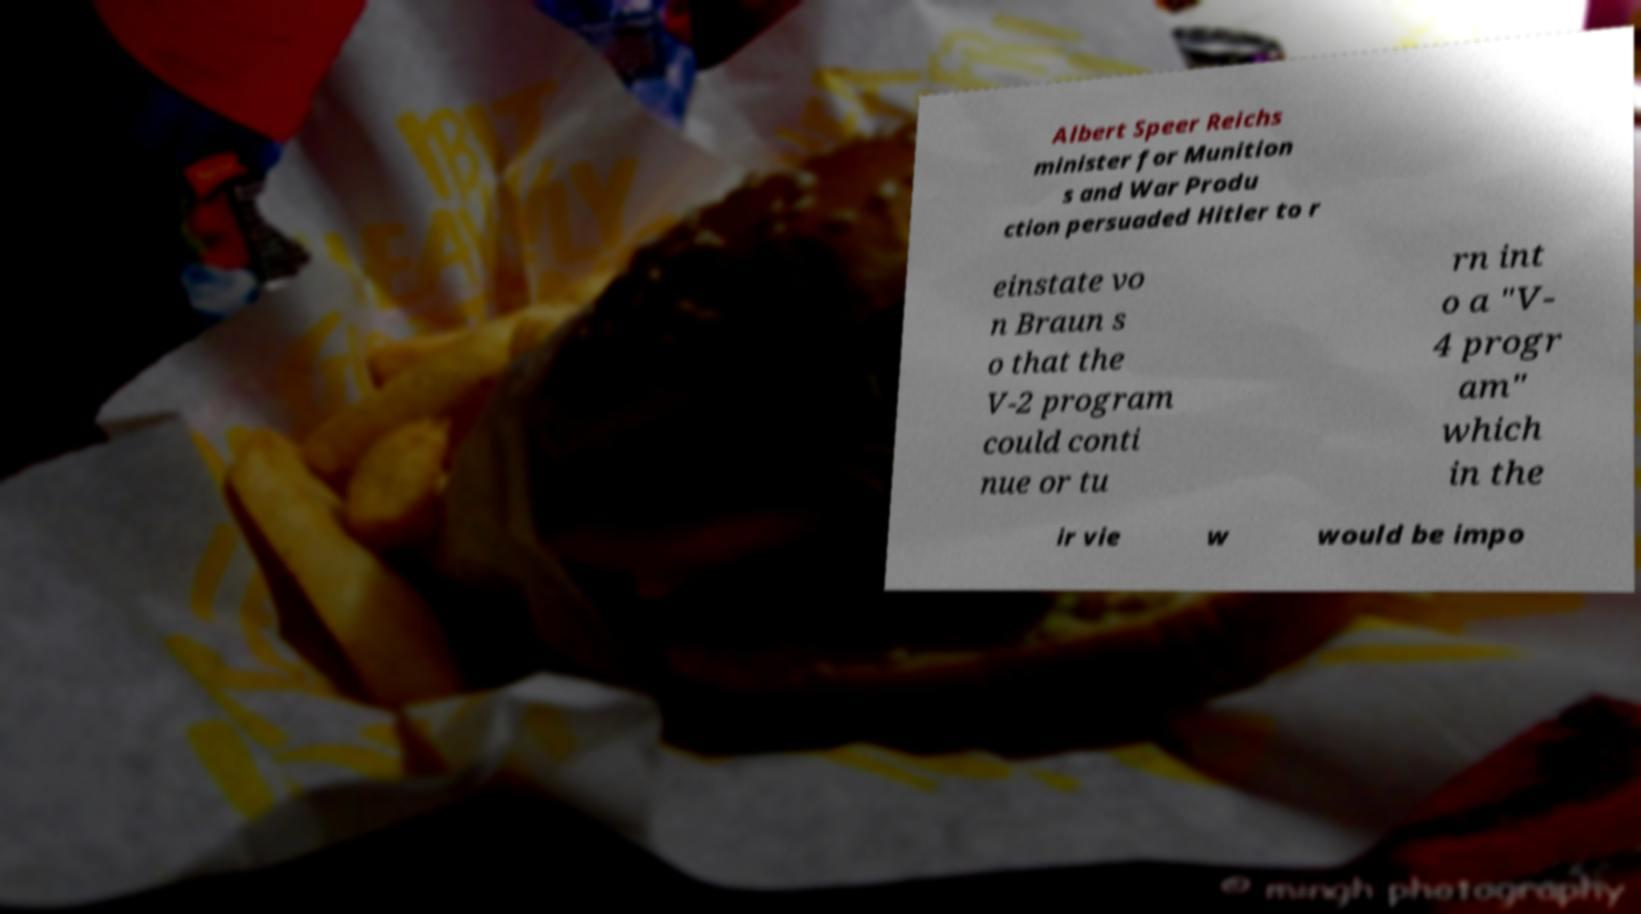For documentation purposes, I need the text within this image transcribed. Could you provide that? Albert Speer Reichs minister for Munition s and War Produ ction persuaded Hitler to r einstate vo n Braun s o that the V-2 program could conti nue or tu rn int o a "V- 4 progr am" which in the ir vie w would be impo 